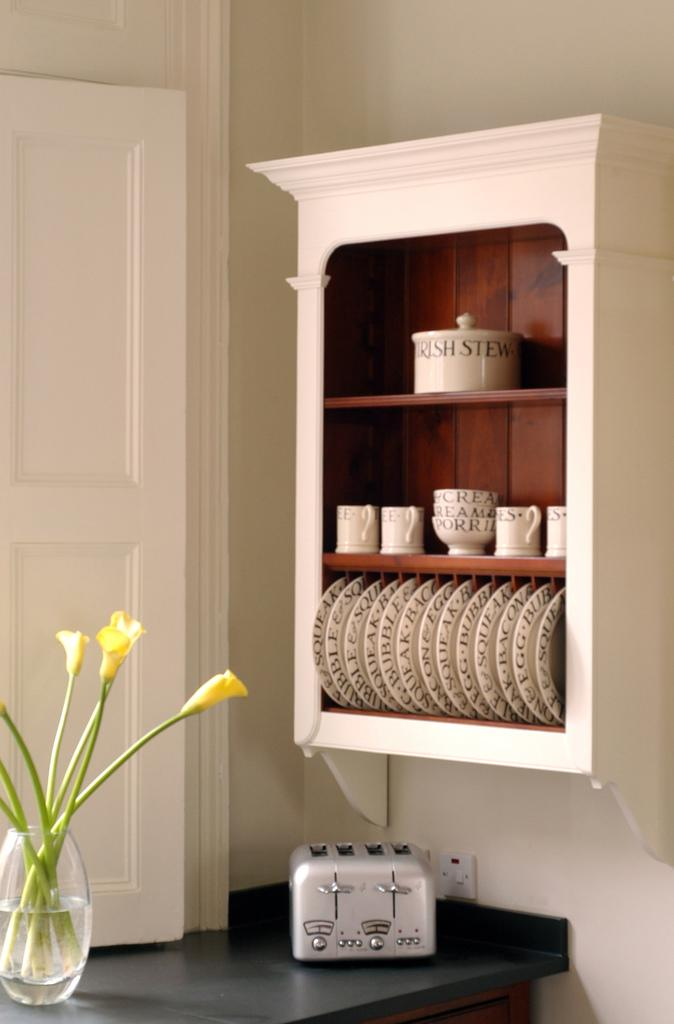<image>
Render a clear and concise summary of the photo. A bowl with "Irish Stew" painted on it is on the top shelf. 